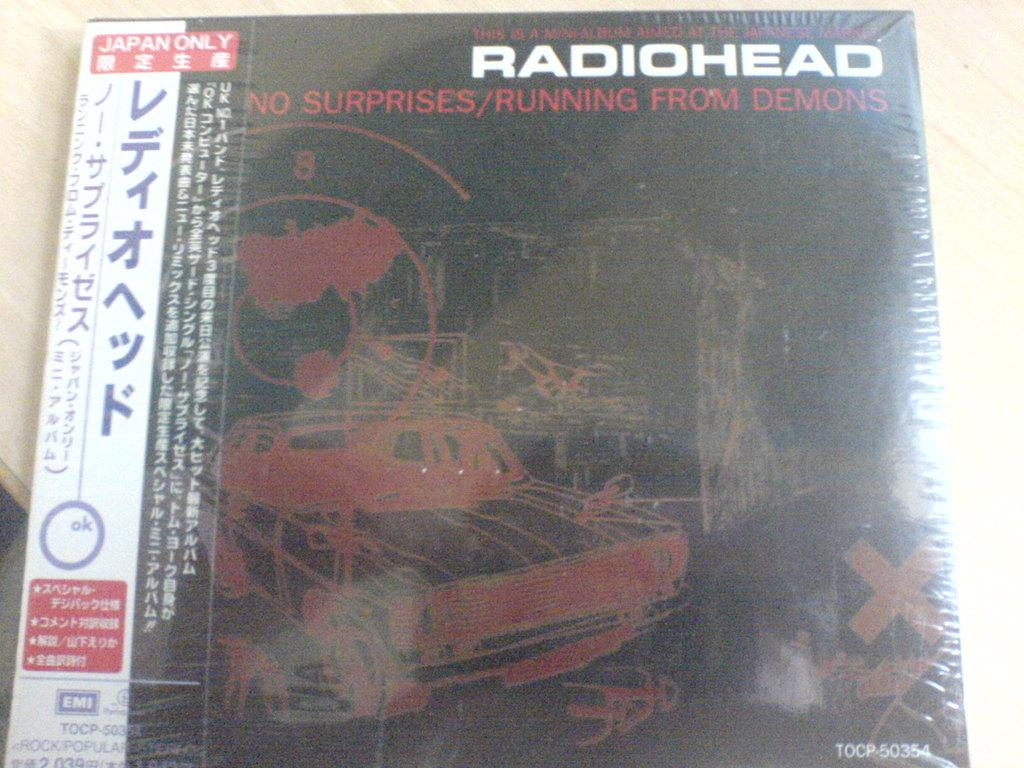<image>
Describe the image concisely. A foreign copy of Radiohead's No Suprises/Running from Demons. 